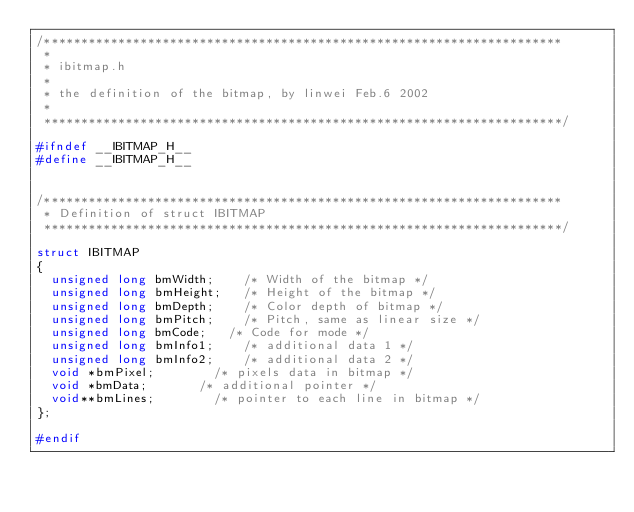Convert code to text. <code><loc_0><loc_0><loc_500><loc_500><_C_>/**********************************************************************
 *
 * ibitmap.h
 *
 * the definition of the bitmap, by linwei Feb.6 2002
 *
 **********************************************************************/

#ifndef __IBITMAP_H__
#define __IBITMAP_H__


/**********************************************************************
 * Definition of struct IBITMAP
 **********************************************************************/

struct IBITMAP
{
	unsigned long bmWidth;		/* Width of the bitmap */
	unsigned long bmHeight;		/* Height of the bitmap */
	unsigned long bmDepth;		/* Color depth of bitmap */
	unsigned long bmPitch;		/* Pitch, same as linear size */
	unsigned long bmCode;		/* Code for mode */
	unsigned long bmInfo1;		/* additional data 1 */
	unsigned long bmInfo2;		/* additional data 2 */
	void *bmPixel;				/* pixels data in bitmap */
	void *bmData;				/* additional pointer */
	void**bmLines;				/* pointer to each line in bitmap */
};

#endif

</code> 